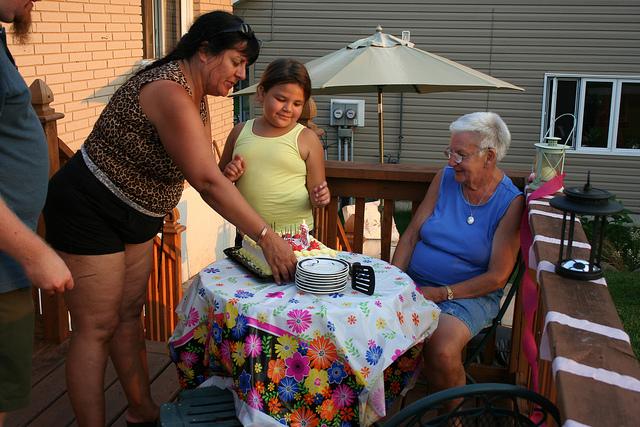Do obese kids grow up to be average weight?
Keep it brief. No. How many people are eating?
Keep it brief. 0. What color is the old lady's shirt?
Concise answer only. Blue. Is there an umbrella in the background?
Write a very short answer. Yes. 